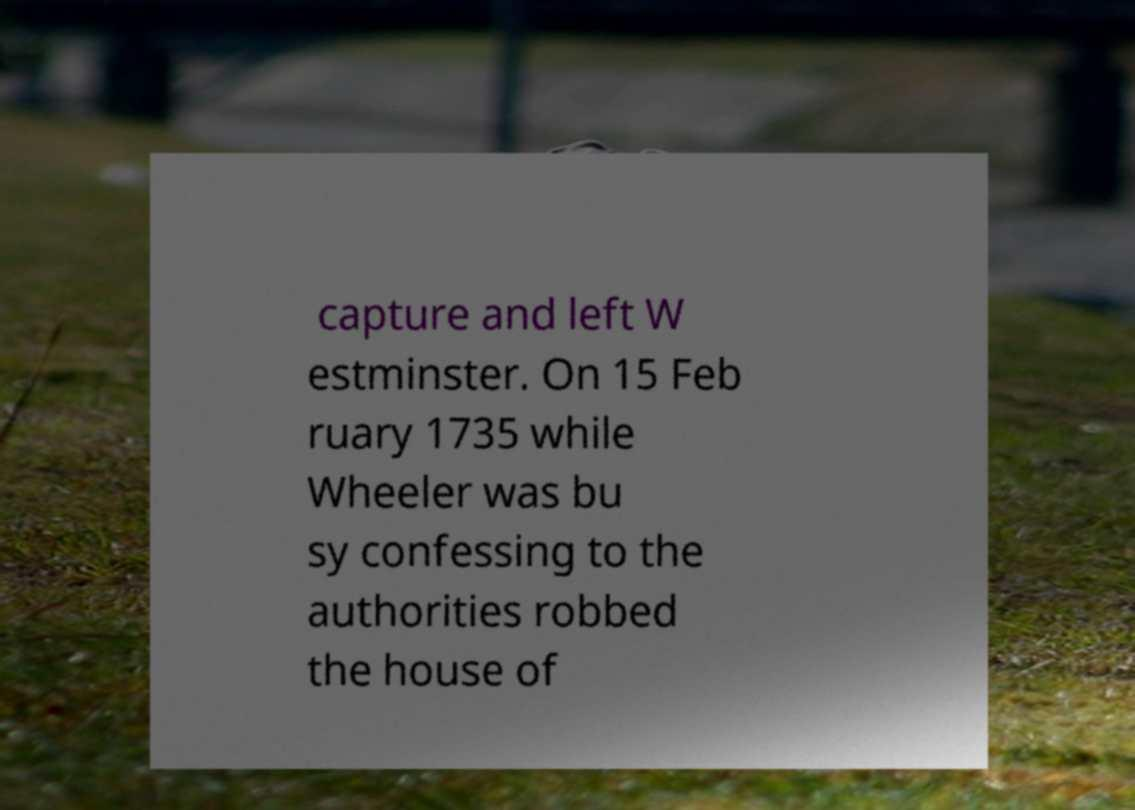What messages or text are displayed in this image? I need them in a readable, typed format. capture and left W estminster. On 15 Feb ruary 1735 while Wheeler was bu sy confessing to the authorities robbed the house of 